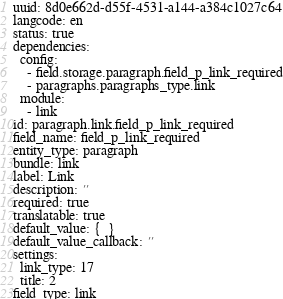<code> <loc_0><loc_0><loc_500><loc_500><_YAML_>uuid: 8d0e662d-d55f-4531-a144-a384c1027c64
langcode: en
status: true
dependencies:
  config:
    - field.storage.paragraph.field_p_link_required
    - paragraphs.paragraphs_type.link
  module:
    - link
id: paragraph.link.field_p_link_required
field_name: field_p_link_required
entity_type: paragraph
bundle: link
label: Link
description: ''
required: true
translatable: true
default_value: {  }
default_value_callback: ''
settings:
  link_type: 17
  title: 2
field_type: link
</code> 